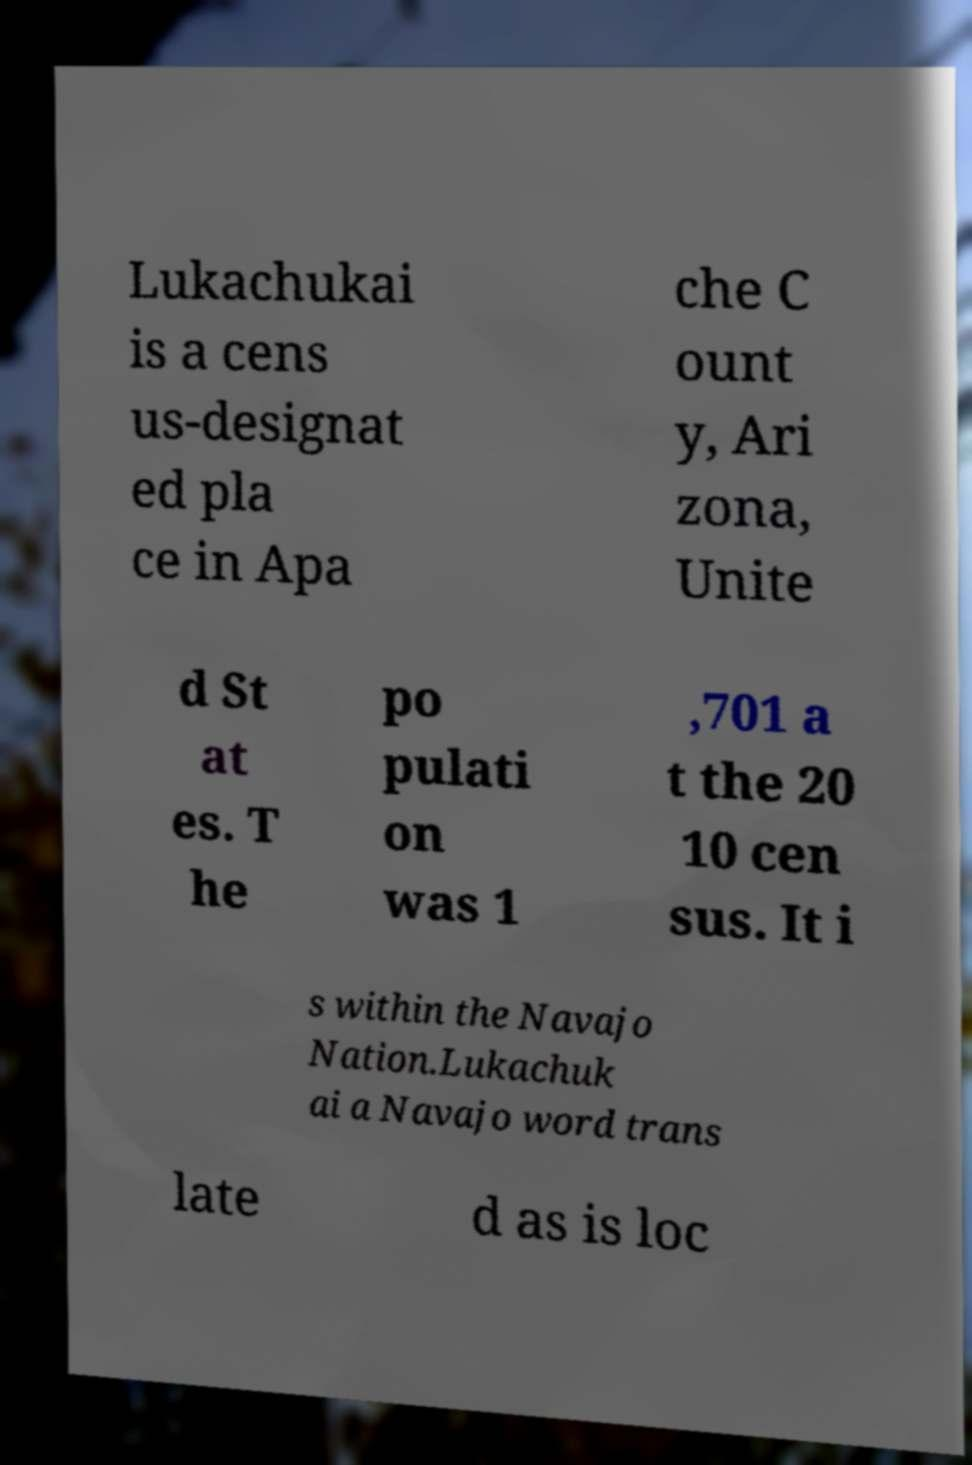Could you assist in decoding the text presented in this image and type it out clearly? Lukachukai is a cens us-designat ed pla ce in Apa che C ount y, Ari zona, Unite d St at es. T he po pulati on was 1 ,701 a t the 20 10 cen sus. It i s within the Navajo Nation.Lukachuk ai a Navajo word trans late d as is loc 